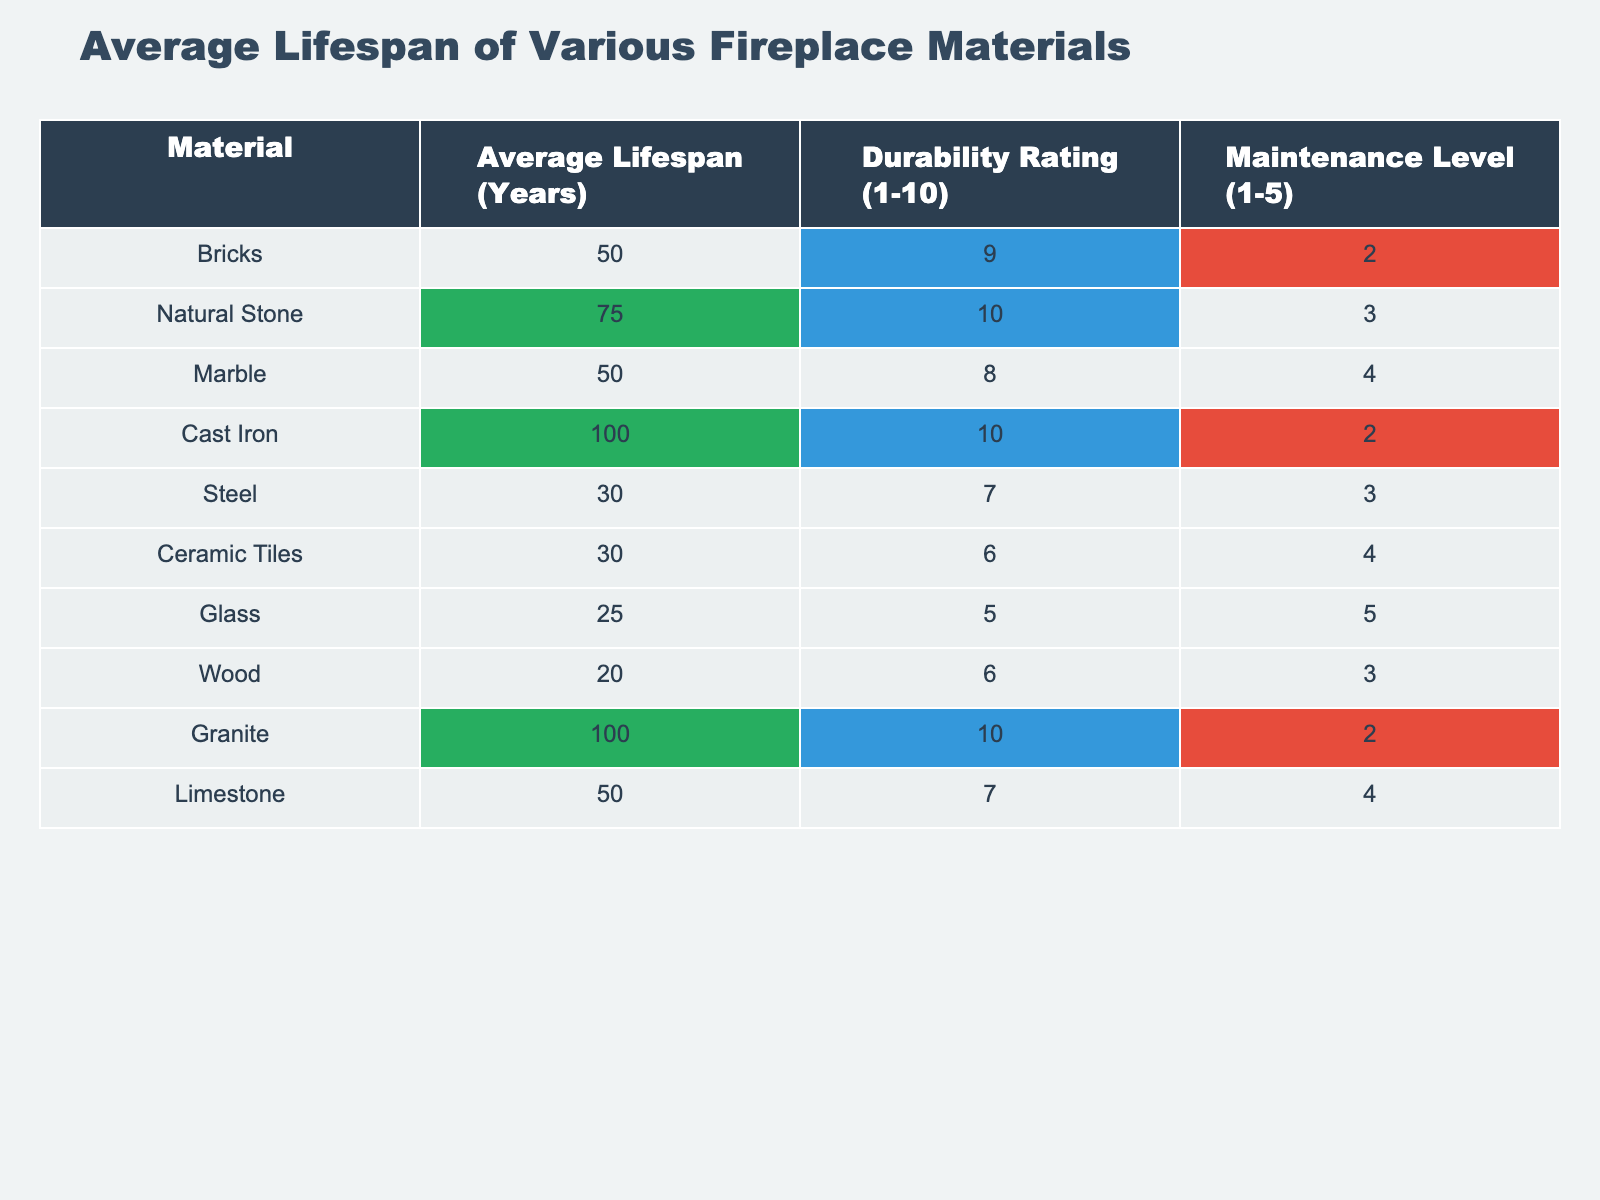What is the average lifespan of natural stone? The table shows that the average lifespan of natural stone is directly listed as 75 years.
Answer: 75 years Which material has the highest durability rating? By looking at the durability ratings in the table, both cast iron and natural stone have the highest rating of 10.
Answer: Cast iron and natural stone How many materials have an average lifespan greater than 50 years? There are three materials with an average lifespan greater than 50 years: natural stone (75), cast iron (100), and granite (100).
Answer: 3 Is it true that ceramic tiles have a maintenance level of less than 3? The table indicates that ceramic tiles have a maintenance level of 4, which is greater than 3, thus the statement is false.
Answer: No Which material is the least durable based on the durability rating? The least durable material is glass, with a durability rating of 5.
Answer: Glass What is the average lifespan of materials with a durability rating of 10? The materials with a durability rating of 10 are cast iron and natural stone, with lifespans of 100 and 75 years, respectively; averaging these gives (100 + 75) / 2 = 87.5 years.
Answer: 87.5 years Among materials that require a maintenance level of 2 or less, which has the longest lifespan? The materials with a maintenance level of 2 or less are bricks (50 years), cast iron (100 years), and granite (100 years). The longest lifespan among these is 100 years (either cast iron or granite).
Answer: 100 years How many materials have an average lifespan less than 30 years? The table shows that glass (25), wood (20), and ceramic tiles (30) have an average lifespan less than 30 years, so there are three materials.
Answer: 3 If you combine the average lifespans of wood and glass, what is their total? The average lifespan of wood is 20 years and glass is 25 years, combining them gives 20 + 25 = 45 years.
Answer: 45 years Which material has the highest maintenance level, and what is its value? The material with the highest maintenance level is glass, with a maintenance level of 5, as indicated in the table.
Answer: Glass, 5 